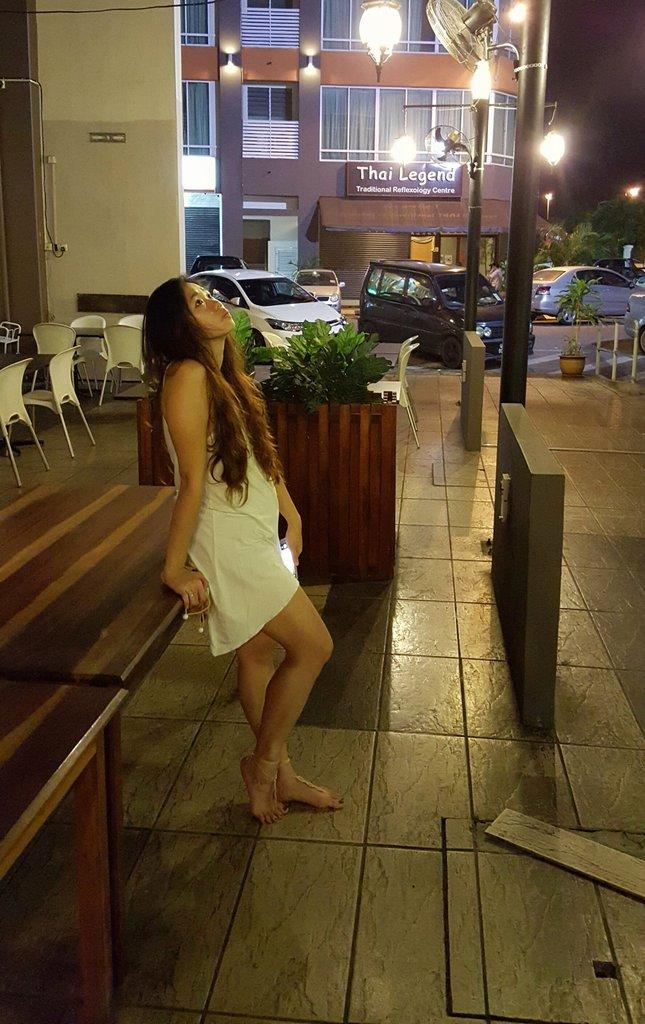What is the main subject in the image? There is a woman standing in the image. What can be seen in the background of the image? There is a small plant in the background. What type of furniture is present in the image? There are chairs in the image. What is the tall, vertical structure in the image? There is a light pole in the image. What is the flat, rectangular object in the image? There is a board in the image. What type of man-made structure is visible in the image? There is a building in the image. How many spiders are crawling on the woman's shoulder in the image? There are no spiders visible on the woman's shoulder in the image. What type of partner is standing next to the woman in the image? There is no partner present in the image; only the woman is visible. 